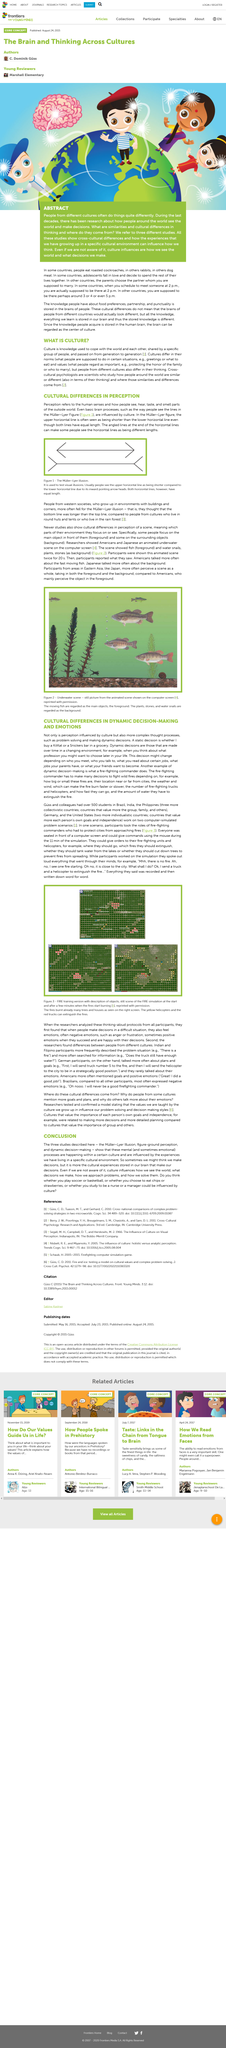Give some essential details in this illustration. The studies described in the conclusion are the Muller-Lyer Illusion, figure-ground perception, and dynamic decision-making. The text mentions seeing, hearing, tasting, and smelling as human senses. Differences in people from different cultures can be seen in their thinking, which is often unique and varied compared to individuals from other backgrounds. The Müller-Lyer figure demonstrates differences in perception between cultures as individuals from different cultures perceive the two lines as having different lengths. The Müller-Lyer Figure fools the sense of sight. 